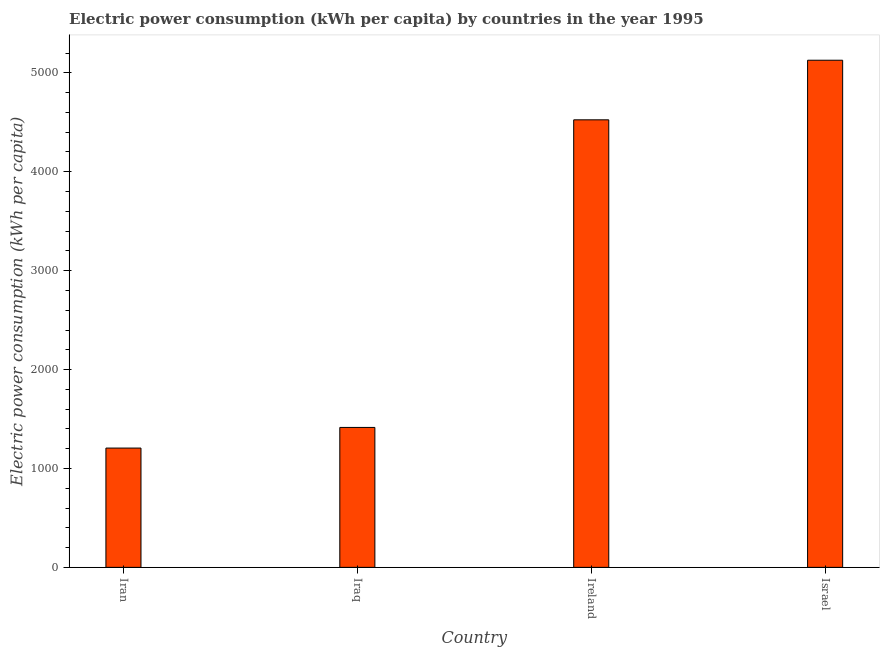Does the graph contain grids?
Provide a short and direct response. No. What is the title of the graph?
Provide a short and direct response. Electric power consumption (kWh per capita) by countries in the year 1995. What is the label or title of the X-axis?
Ensure brevity in your answer.  Country. What is the label or title of the Y-axis?
Ensure brevity in your answer.  Electric power consumption (kWh per capita). What is the electric power consumption in Israel?
Offer a very short reply. 5127.86. Across all countries, what is the maximum electric power consumption?
Keep it short and to the point. 5127.86. Across all countries, what is the minimum electric power consumption?
Give a very brief answer. 1206.14. In which country was the electric power consumption maximum?
Make the answer very short. Israel. In which country was the electric power consumption minimum?
Ensure brevity in your answer.  Iran. What is the sum of the electric power consumption?
Provide a short and direct response. 1.23e+04. What is the difference between the electric power consumption in Iran and Iraq?
Your answer should be compact. -208.8. What is the average electric power consumption per country?
Keep it short and to the point. 3068.56. What is the median electric power consumption?
Your answer should be compact. 2970.11. What is the ratio of the electric power consumption in Iraq to that in Israel?
Offer a very short reply. 0.28. Is the electric power consumption in Ireland less than that in Israel?
Your response must be concise. Yes. What is the difference between the highest and the second highest electric power consumption?
Your response must be concise. 602.59. What is the difference between the highest and the lowest electric power consumption?
Keep it short and to the point. 3921.72. How many bars are there?
Make the answer very short. 4. Are all the bars in the graph horizontal?
Your response must be concise. No. How many countries are there in the graph?
Provide a succinct answer. 4. What is the difference between two consecutive major ticks on the Y-axis?
Your answer should be compact. 1000. Are the values on the major ticks of Y-axis written in scientific E-notation?
Offer a terse response. No. What is the Electric power consumption (kWh per capita) of Iran?
Make the answer very short. 1206.14. What is the Electric power consumption (kWh per capita) in Iraq?
Your answer should be compact. 1414.94. What is the Electric power consumption (kWh per capita) in Ireland?
Offer a very short reply. 4525.28. What is the Electric power consumption (kWh per capita) in Israel?
Offer a very short reply. 5127.86. What is the difference between the Electric power consumption (kWh per capita) in Iran and Iraq?
Make the answer very short. -208.8. What is the difference between the Electric power consumption (kWh per capita) in Iran and Ireland?
Your answer should be compact. -3319.13. What is the difference between the Electric power consumption (kWh per capita) in Iran and Israel?
Give a very brief answer. -3921.72. What is the difference between the Electric power consumption (kWh per capita) in Iraq and Ireland?
Provide a short and direct response. -3110.33. What is the difference between the Electric power consumption (kWh per capita) in Iraq and Israel?
Ensure brevity in your answer.  -3712.92. What is the difference between the Electric power consumption (kWh per capita) in Ireland and Israel?
Make the answer very short. -602.59. What is the ratio of the Electric power consumption (kWh per capita) in Iran to that in Iraq?
Your answer should be very brief. 0.85. What is the ratio of the Electric power consumption (kWh per capita) in Iran to that in Ireland?
Give a very brief answer. 0.27. What is the ratio of the Electric power consumption (kWh per capita) in Iran to that in Israel?
Your answer should be very brief. 0.23. What is the ratio of the Electric power consumption (kWh per capita) in Iraq to that in Ireland?
Keep it short and to the point. 0.31. What is the ratio of the Electric power consumption (kWh per capita) in Iraq to that in Israel?
Keep it short and to the point. 0.28. What is the ratio of the Electric power consumption (kWh per capita) in Ireland to that in Israel?
Your response must be concise. 0.88. 